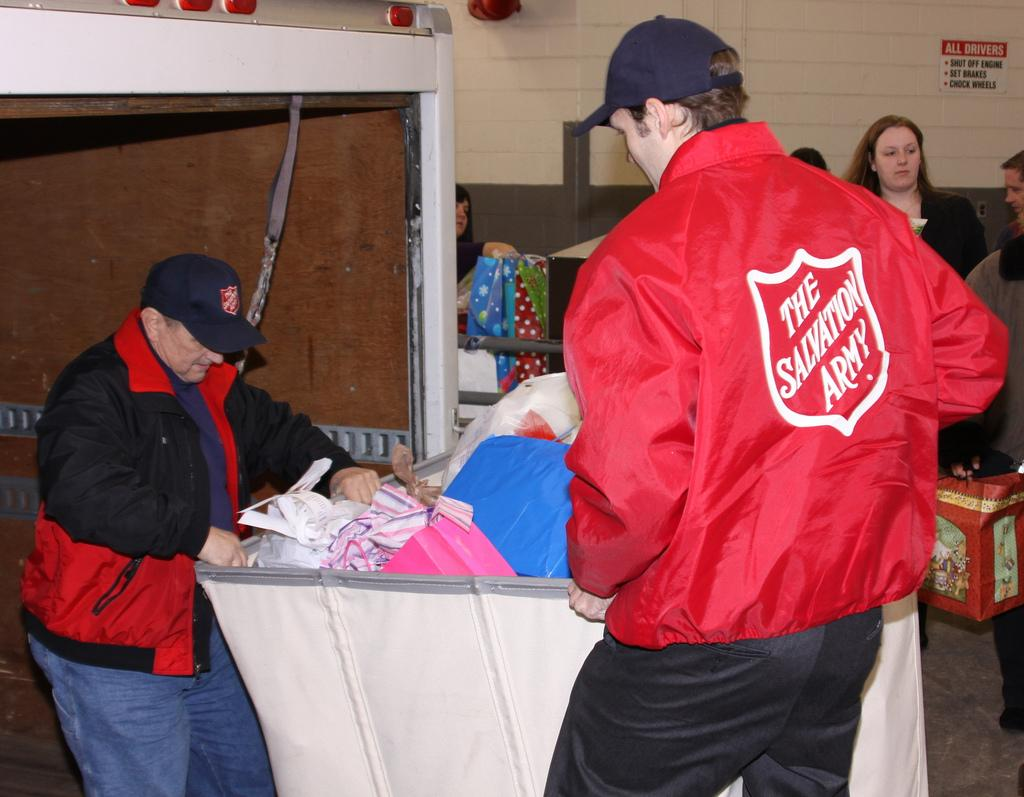<image>
Present a compact description of the photo's key features. Two Salvation Army workers push a cart containing donated items in a receiving area. 